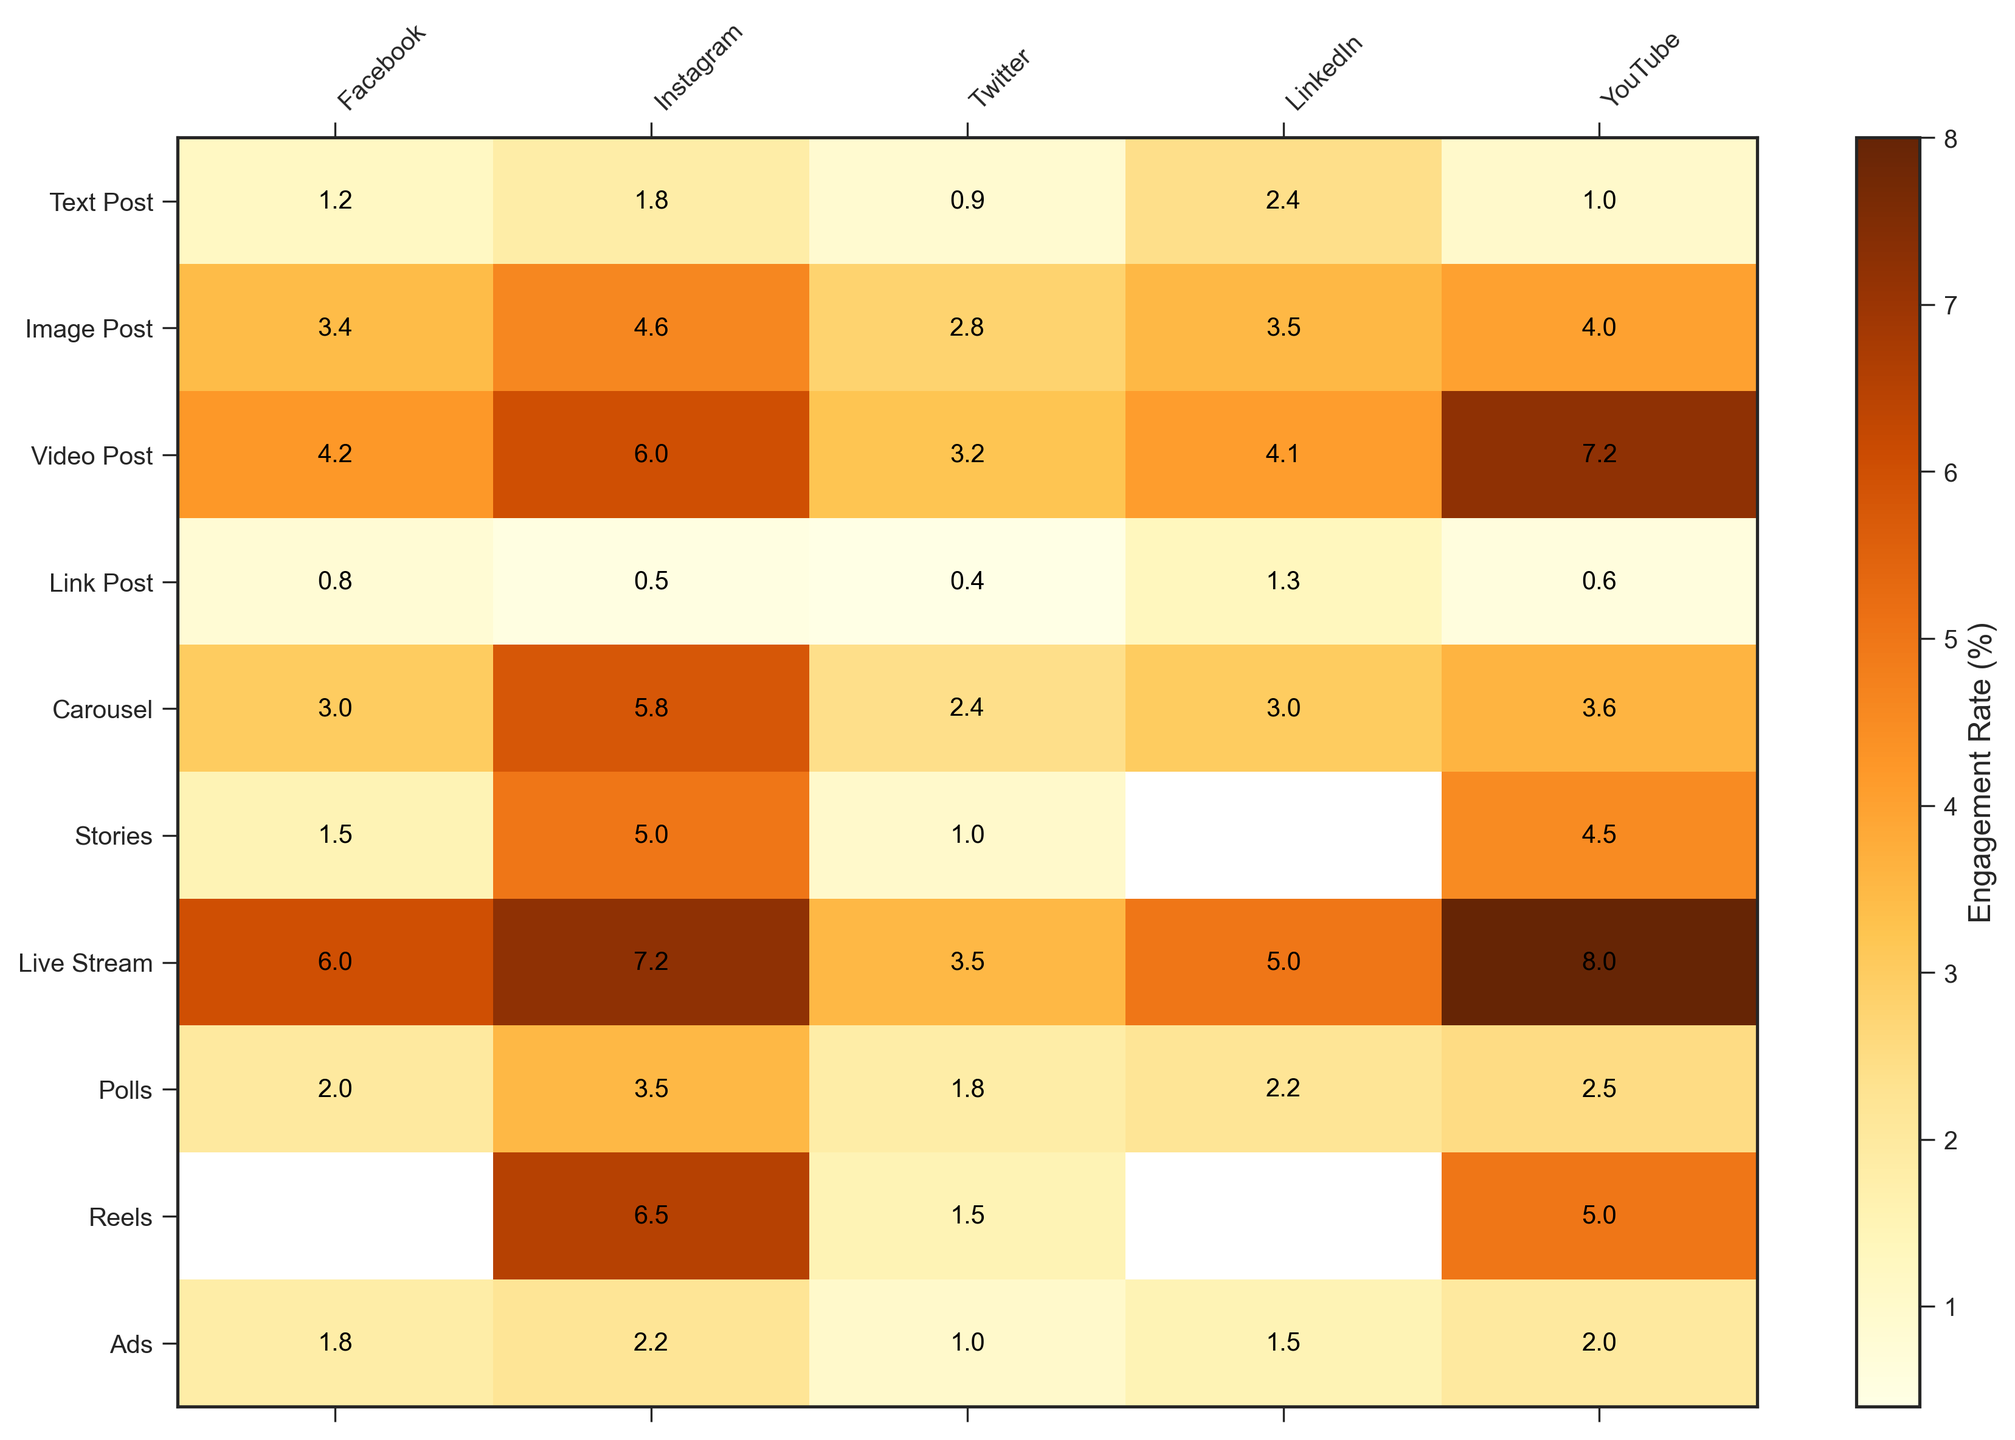What type of content has the highest engagement rate on Instagram? Look at the Instagram column and find the highest value, which corresponds to Live Stream with an engagement rate of 7.2%.
Answer: Live Stream What is the average engagement rate of a Video Post across all platforms? Sum the engagement rates of Video Post on all platforms (4.2 + 6.0 + 3.2 + 4.1 + 7.2) = 24.7 and divide by the number of platforms (5). The average engagement rate is 24.7 / 5 = 4.94%.
Answer: 4.94% Which content type has a higher engagement rate on Twitter: Image Post or Carousel? Compare the engagement rates on Twitter for Image Post (2.8) and Carousel (2.4). Image Post has a higher engagement rate.
Answer: Image Post How much higher is the engagement rate for Live Stream compared to Link Post on YouTube? Subtract the engagement rate of Link Post on YouTube (0.6) from the engagement rate of Live Stream on YouTube (8.0). 8.0 - 0.6 = 7.4
Answer: 7.4 Which platform has the lowest engagement rate for Stories? Look at the engagement rates for Stories across all platforms. Twitter has the lowest engagement rate with a value of 1.0.
Answer: Twitter What is the difference in engagement rate between Carousel and Text Post on LinkedIn? Subtract the LinkedIn engagement rate for Text Post (2.4) from that for Carousel (3.0). 3.0 - 2.4 = 0.6
Answer: 0.6 Which content type has a varying engagement rate across platforms and what is the range of its values? Check "Video Post" where the rates range from 3.2 (Twitter) to 7.2 (YouTube). The range is calculated by subtracting the lowest value from the highest value, 7.2 - 3.2 = 4.0.
Answer: Video Post, 4.0 What is the combined engagement rate of Reels on Instagram and YouTube? Sum the engagement rates for Reels on Instagram (6.5) and YouTube (5.0), 6.5 + 5.0 = 11.5.
Answer: 11.5 Which content type has a consistent ranking across all platforms? Look at each content type and check if the relative ranking stays constant. None of the content types have a consistent relative ranking across all platforms.
Answer: None 